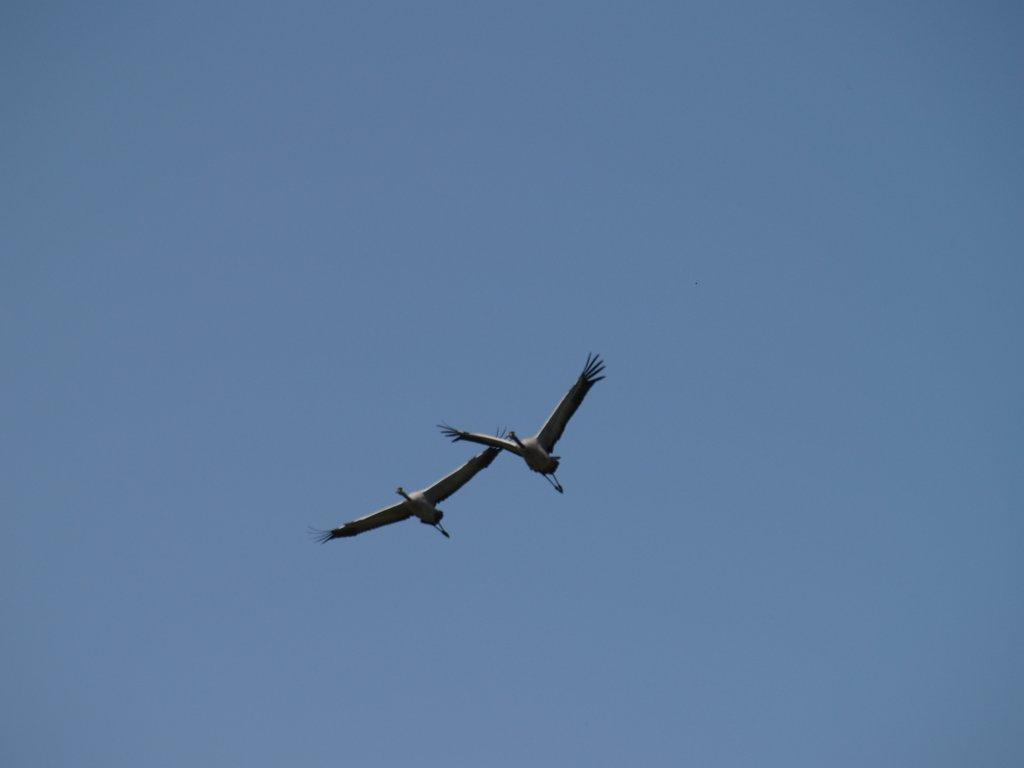What animals can be seen in the image? There are two birds flying in the image. What is visible in the background of the image? The sky is visible in the background of the image. Where is the marble located in the image? There is no marble present in the image. What does the lunchroom have to do with the birds in the image? The image does not depict a lunchroom, and the birds are not related to a lunchroom. 